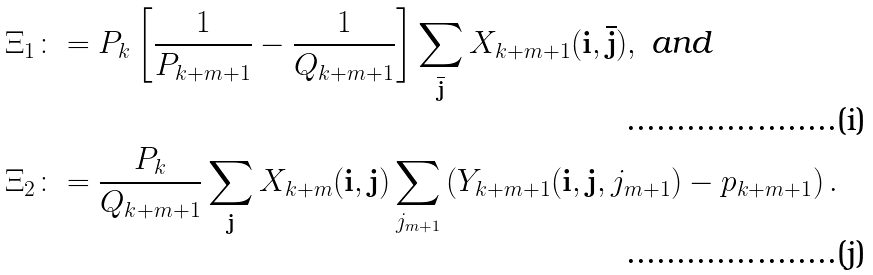Convert formula to latex. <formula><loc_0><loc_0><loc_500><loc_500>\Xi _ { 1 } & \colon = P _ { k } \left [ \frac { 1 } { P _ { k + m + 1 } } - \frac { 1 } { Q _ { k + m + 1 } } \right ] \sum _ { \overline { \mathbf j } } X _ { k + m + 1 } ( \mathbf i , \overline { \mathbf j } ) , \text { and } \\ \Xi _ { 2 } & \colon = \frac { P _ { k } } { Q _ { k + m + 1 } } \sum _ { \mathbf j } X _ { k + m } ( \mathbf i , \mathbf j ) \sum _ { j _ { m + 1 } } \left ( Y _ { k + m + 1 } ( \mathbf i , \mathbf j , j _ { m + 1 } ) - p _ { k + m + 1 } \right ) .</formula> 